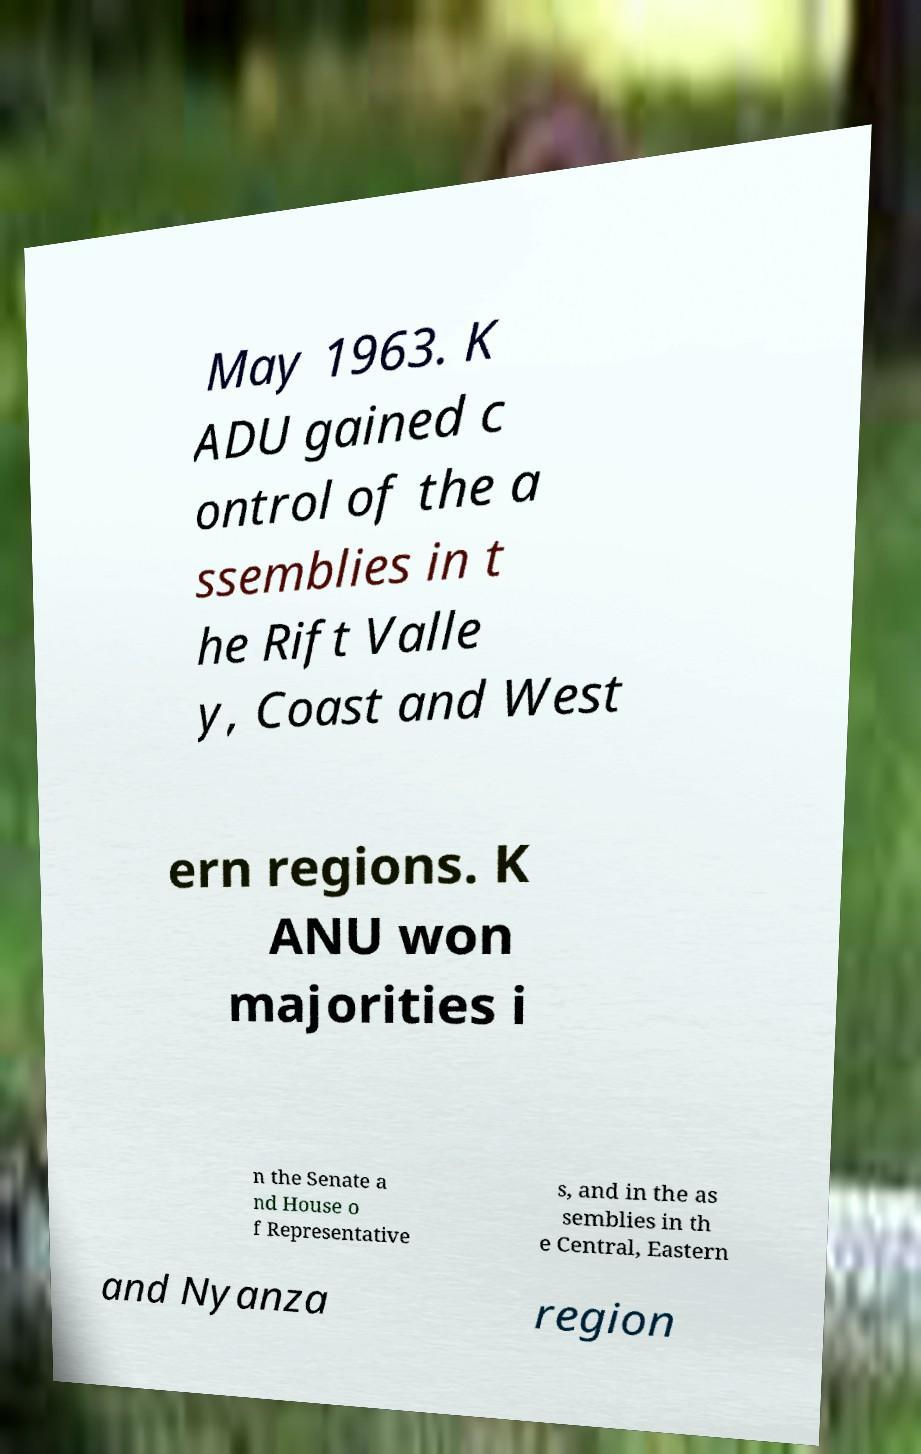Please identify and transcribe the text found in this image. May 1963. K ADU gained c ontrol of the a ssemblies in t he Rift Valle y, Coast and West ern regions. K ANU won majorities i n the Senate a nd House o f Representative s, and in the as semblies in th e Central, Eastern and Nyanza region 